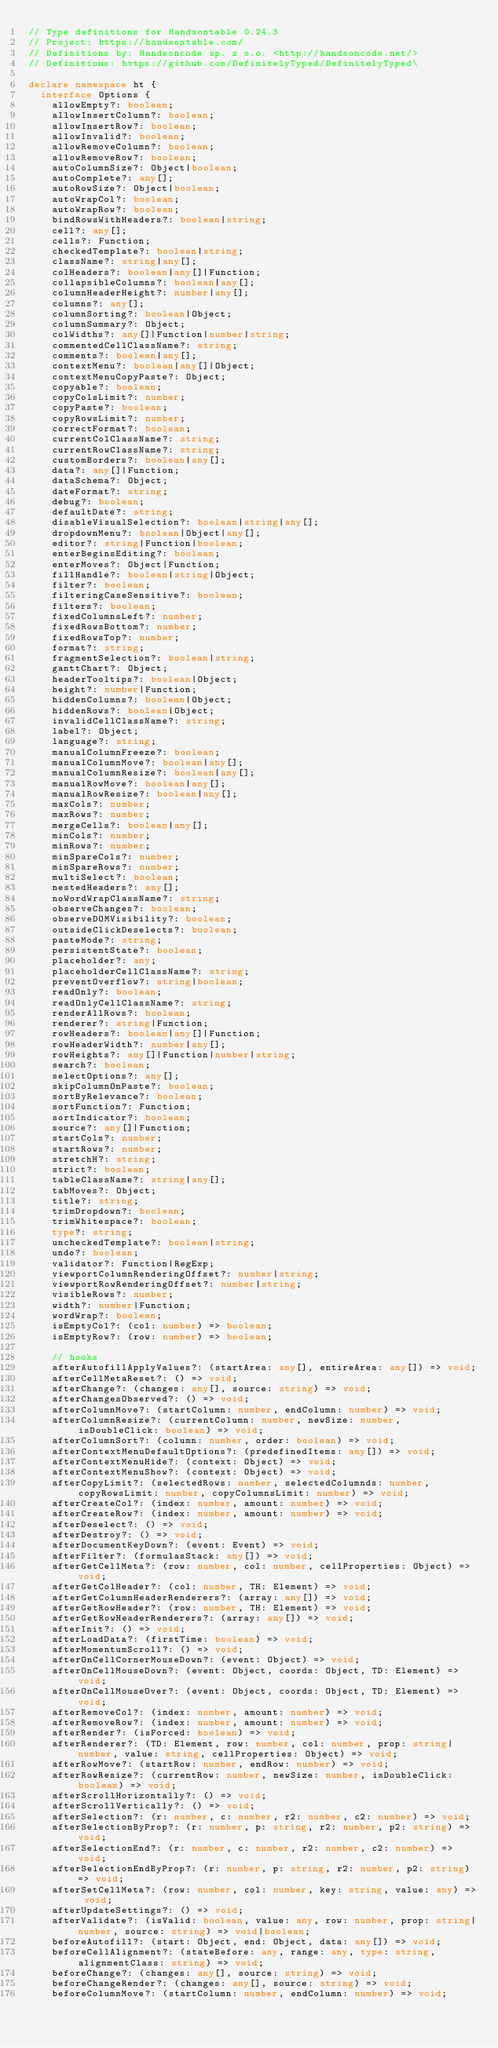Convert code to text. <code><loc_0><loc_0><loc_500><loc_500><_TypeScript_>// Type definitions for Handsontable 0.24.3
// Project: https://handsontable.com/
// Definitions by: Handsoncode sp. z o.o. <http://handsoncode.net/>
// Definitions: https://github.com/DefinitelyTyped/DefinitelyTyped\

declare namespace ht {
  interface Options {
    allowEmpty?: boolean;
    allowInsertColumn?: boolean;
    allowInsertRow?: boolean;
    allowInvalid?: boolean;
    allowRemoveColumn?: boolean;
    allowRemoveRow?: boolean;
    autoColumnSize?: Object|boolean;
    autoComplete?: any[];
    autoRowSize?: Object|boolean;
    autoWrapCol?: boolean;
    autoWrapRow?: boolean;
    bindRowsWithHeaders?: boolean|string;
    cell?: any[];
    cells?: Function;
    checkedTemplate?: boolean|string;
    className?: string|any[];
    colHeaders?: boolean|any[]|Function;
    collapsibleColumns?: boolean|any[];
    columnHeaderHeight?: number|any[];
    columns?: any[];
    columnSorting?: boolean|Object;
    columnSummary?: Object;
    colWidths?: any[]|Function|number|string;
    commentedCellClassName?: string;
    comments?: boolean|any[];
    contextMenu?: boolean|any[]|Object;
    contextMenuCopyPaste?: Object;
    copyable?: boolean;
    copyColsLimit?: number;
    copyPaste?: boolean;
    copyRowsLimit?: number;
    correctFormat?: boolean;
    currentColClassName?: string;
    currentRowClassName?: string;
    customBorders?: boolean|any[];
    data?: any[]|Function;
    dataSchema?: Object;
    dateFormat?: string;
    debug?: boolean;
    defaultDate?: string;
    disableVisualSelection?: boolean|string|any[];
    dropdownMenu?: boolean|Object|any[];
    editor?: string|Function|boolean;
    enterBeginsEditing?: boolean;
    enterMoves?: Object|Function;
    fillHandle?: boolean|string|Object;
    filter?: boolean;
    filteringCaseSensitive?: boolean;
    filters?: boolean;
    fixedColumnsLeft?: number;
    fixedRowsBottom?: number;
    fixedRowsTop?: number;
    format?: string;
    fragmentSelection?: boolean|string;
    ganttChart?: Object;
    headerTooltips?: boolean|Object;
    height?: number|Function;
    hiddenColumns?: boolean|Object;
    hiddenRows?: boolean|Object;
    invalidCellClassName?: string;
    label?: Object;
    language?: string;
    manualColumnFreeze?: boolean;
    manualColumnMove?: boolean|any[];
    manualColumnResize?: boolean|any[];
    manualRowMove?: boolean|any[];
    manualRowResize?: boolean|any[];
    maxCols?: number;
    maxRows?: number;
    mergeCells?: boolean|any[];
    minCols?: number;
    minRows?: number;
    minSpareCols?: number;
    minSpareRows?: number;
    multiSelect?: boolean;
    nestedHeaders?: any[];
    noWordWrapClassName?: string;
    observeChanges?: boolean;
    observeDOMVisibility?: boolean;
    outsideClickDeselects?: boolean;
    pasteMode?: string;
    persistentState?: boolean;
    placeholder?: any;
    placeholderCellClassName?: string;
    preventOverflow?: string|boolean;
    readOnly?: boolean;
    readOnlyCellClassName?: string;
    renderAllRows?: boolean;
    renderer?: string|Function;
    rowHeaders?: boolean|any[]|Function;
    rowHeaderWidth?: number|any[];
    rowHeights?: any[]|Function|number|string;
    search?: boolean;
    selectOptions?: any[];
    skipColumnOnPaste?: boolean;
    sortByRelevance?: boolean;
    sortFunction?: Function;
    sortIndicator?: boolean;
    source?: any[]|Function;
    startCols?: number;
    startRows?: number;
    stretchH?: string;
    strict?: boolean;
    tableClassName?: string|any[];
    tabMoves?: Object;
    title?: string;
    trimDropdown?: boolean;
    trimWhitespace?: boolean;
    type?: string;
    uncheckedTemplate?: boolean|string;
    undo?: boolean;
    validator?: Function|RegExp;
    viewportColumnRenderingOffset?: number|string;
    viewportRowRenderingOffset?: number|string;
    visibleRows?: number;
    width?: number|Function;
    wordWrap?: boolean;
    isEmptyCol?: (col: number) => boolean;
    isEmptyRow?: (row: number) => boolean;

    // hooks
    afterAutofillApplyValues?: (startArea: any[], entireArea: any[]) => void;
    afterCellMetaReset?: () => void;
    afterChange?: (changes: any[], source: string) => void;
    afterChangesObserved?: () => void;
    afterColumnMove?: (startColumn: number, endColumn: number) => void;
    afterColumnResize?: (currentColumn: number, newSize: number, isDoubleClick: boolean) => void;
    afterColumnSort?: (column: number, order: boolean) => void;
    afterContextMenuDefaultOptions?: (predefinedItems: any[]) => void;
    afterContextMenuHide?: (context: Object) => void;
    afterContextMenuShow?: (context: Object) => void;
    afterCopyLimit?: (selectedRows: number, selectedColumnds: number, copyRowsLimit: number, copyColumnsLimit: number) => void;
    afterCreateCol?: (index: number, amount: number) => void;
    afterCreateRow?: (index: number, amount: number) => void;
    afterDeselect?: () => void;
    afterDestroy?: () => void;
    afterDocumentKeyDown?: (event: Event) => void;
    afterFilter?: (formulasStack: any[]) => void;
    afterGetCellMeta?: (row: number, col: number, cellProperties: Object) => void;
    afterGetColHeader?: (col: number, TH: Element) => void;
    afterGetColumnHeaderRenderers?: (array: any[]) => void;
    afterGetRowHeader?: (row: number, TH: Element) => void;
    afterGetRowHeaderRenderers?: (array: any[]) => void;
    afterInit?: () => void;
    afterLoadData?: (firstTime: boolean) => void;
    afterMomentumScroll?: () => void;
    afterOnCellCornerMouseDown?: (event: Object) => void;
    afterOnCellMouseDown?: (event: Object, coords: Object, TD: Element) => void;
    afterOnCellMouseOver?: (event: Object, coords: Object, TD: Element) => void;
    afterRemoveCol?: (index: number, amount: number) => void;
    afterRemoveRow?: (index: number, amount: number) => void;
    afterRender?: (isForced: boolean) => void;
    afterRenderer?: (TD: Element, row: number, col: number, prop: string|number, value: string, cellProperties: Object) => void;
    afterRowMove?: (startRow: number, endRow: number) => void;
    afterRowResize?: (currentRow: number, newSize: number, isDoubleClick: boolean) => void;
    afterScrollHorizontally?: () => void;
    afterScrollVertically?: () => void;
    afterSelection?: (r: number, c: number, r2: number, c2: number) => void;
    afterSelectionByProp?: (r: number, p: string, r2: number, p2: string) => void;
    afterSelectionEnd?: (r: number, c: number, r2: number, c2: number) => void;
    afterSelectionEndByProp?: (r: number, p: string, r2: number, p2: string) => void;
    afterSetCellMeta?: (row: number, col: number, key: string, value: any) => void;
    afterUpdateSettings?: () => void;
    afterValidate?: (isValid: boolean, value: any, row: number, prop: string|number, source: string) => void|boolean;
    beforeAutofill?: (start: Object, end: Object, data: any[]) => void;
    beforeCellAlignment?: (stateBefore: any, range: any, type: string, alignmentClass: string) => void;
    beforeChange?: (changes: any[], source: string) => void;
    beforeChangeRender?: (changes: any[], source: string) => void;
    beforeColumnMove?: (startColumn: number, endColumn: number) => void;</code> 